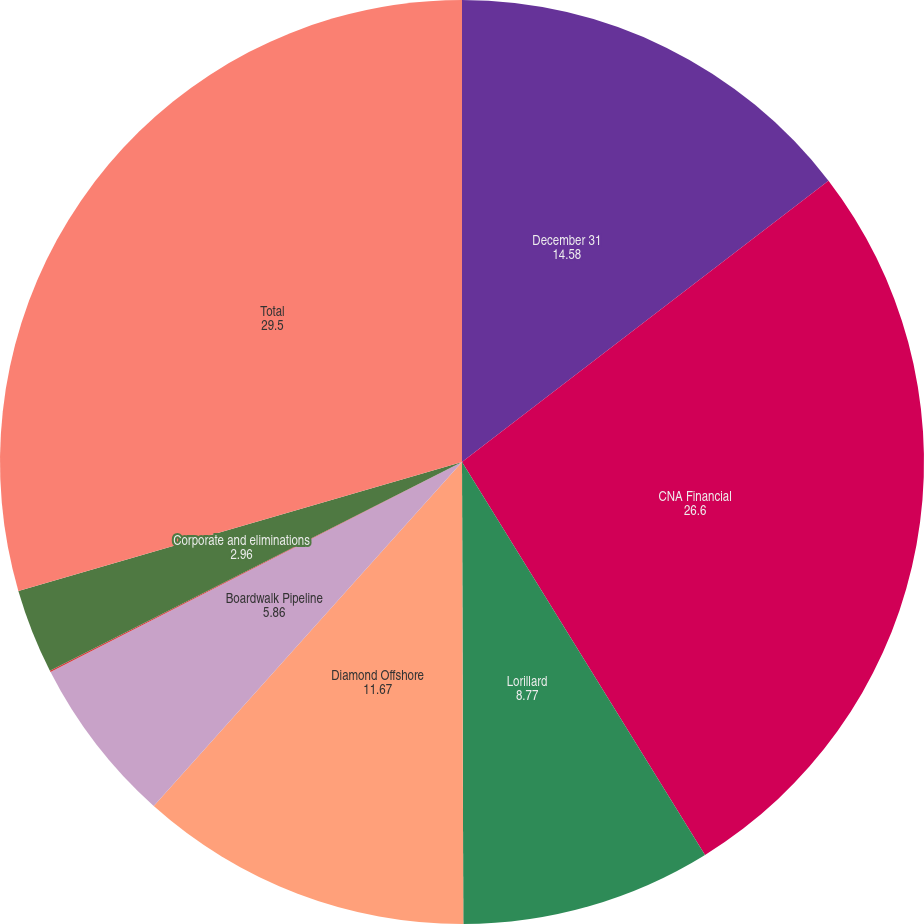Convert chart to OTSL. <chart><loc_0><loc_0><loc_500><loc_500><pie_chart><fcel>December 31<fcel>CNA Financial<fcel>Lorillard<fcel>Diamond Offshore<fcel>Boardwalk Pipeline<fcel>Loews Hotels<fcel>Corporate and eliminations<fcel>Total<nl><fcel>14.58%<fcel>26.6%<fcel>8.77%<fcel>11.67%<fcel>5.86%<fcel>0.05%<fcel>2.96%<fcel>29.5%<nl></chart> 